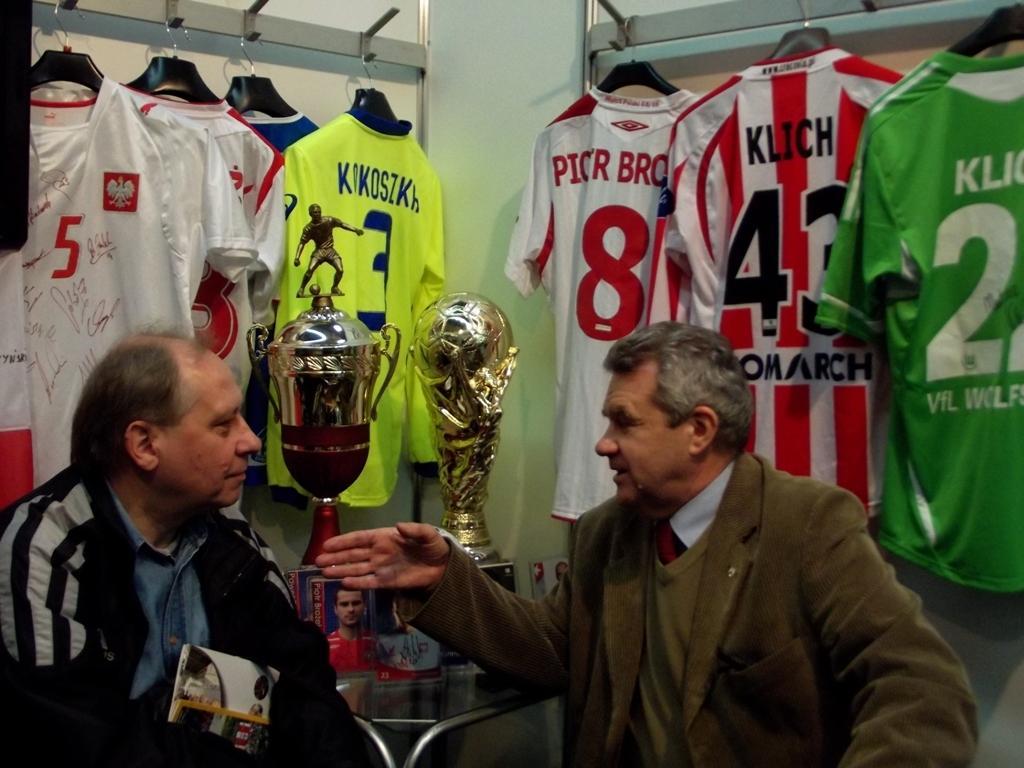<image>
Present a compact description of the photo's key features. Two men talk to each other in a room in front of trophies and sports jerseys including one for the Monarch player number 43, Klich. 